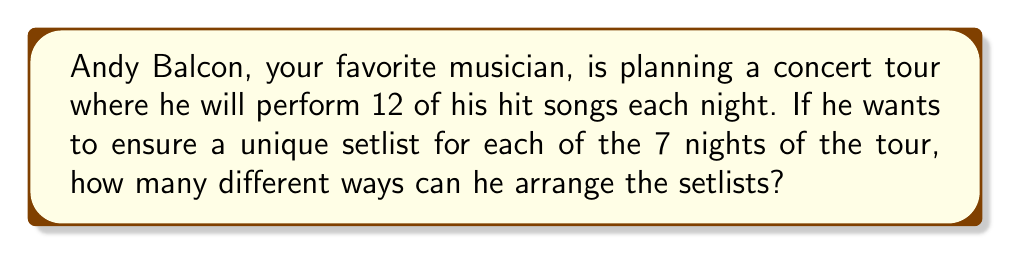Provide a solution to this math problem. Let's approach this step-by-step:

1) First, we need to understand that this is a permutation problem. We're selecting all 12 songs each night, but the order matters.

2) For the first night, Andy has 12 choices for the first song, 11 for the second, 10 for the third, and so on. This gives us:

   $$12! = 12 \times 11 \times 10 \times ... \times 2 \times 1 = 479,001,600$$

   possible arrangements for the first night.

3) For the second night, we want a completely different arrangement. So we have 12! - 1 choices.

4) For the third night, we have 12! - 2 choices, and so on.

5) Therefore, the total number of ways to arrange the setlists for all 7 nights is:

   $$12! \times (12! - 1) \times (12! - 2) \times ... \times (12! - 6)$$

6) We can simplify this as:

   $$12! \times (12! - 1) \times (12! - 2) \times (12! - 3) \times (12! - 4) \times (12! - 5) \times (12! - 6)$$

7) This number is extremely large. To give an idea of its magnitude:

   $$479,001,600 \times 479,001,599 \times 479,001,598 \times ... \times 479,001,594$$

8) This result is a 55-digit number, far too large to calculate by hand or with most standard calculators.
Answer: $$12! \times (12! - 1) \times (12! - 2) \times (12! - 3) \times (12! - 4) \times (12! - 5) \times (12! - 6)$$ 